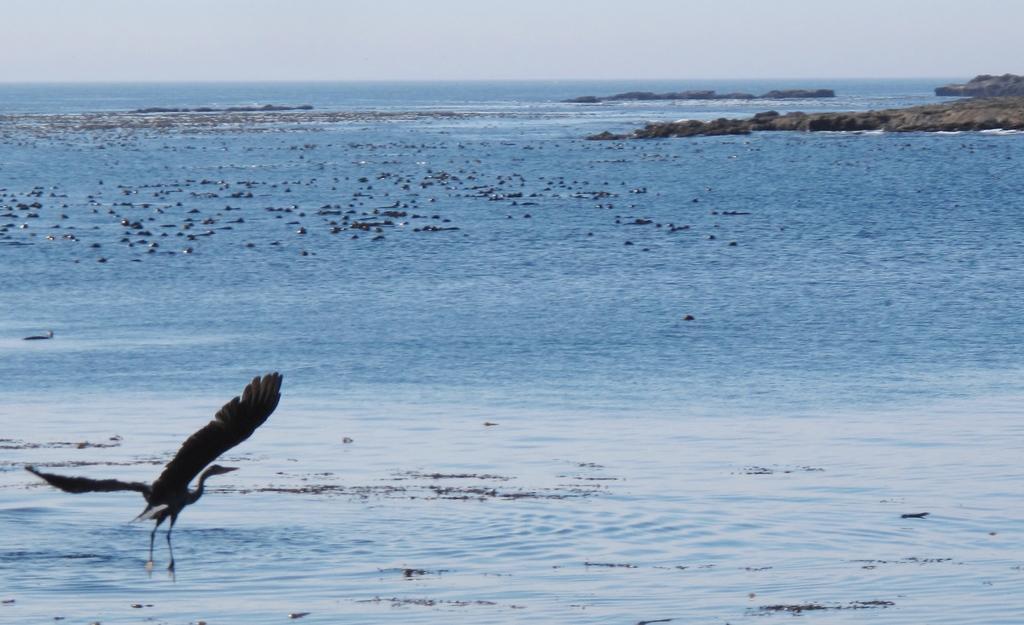Could you give a brief overview of what you see in this image? In the image we can see a bird flying, this is a water, stones and a sky. 